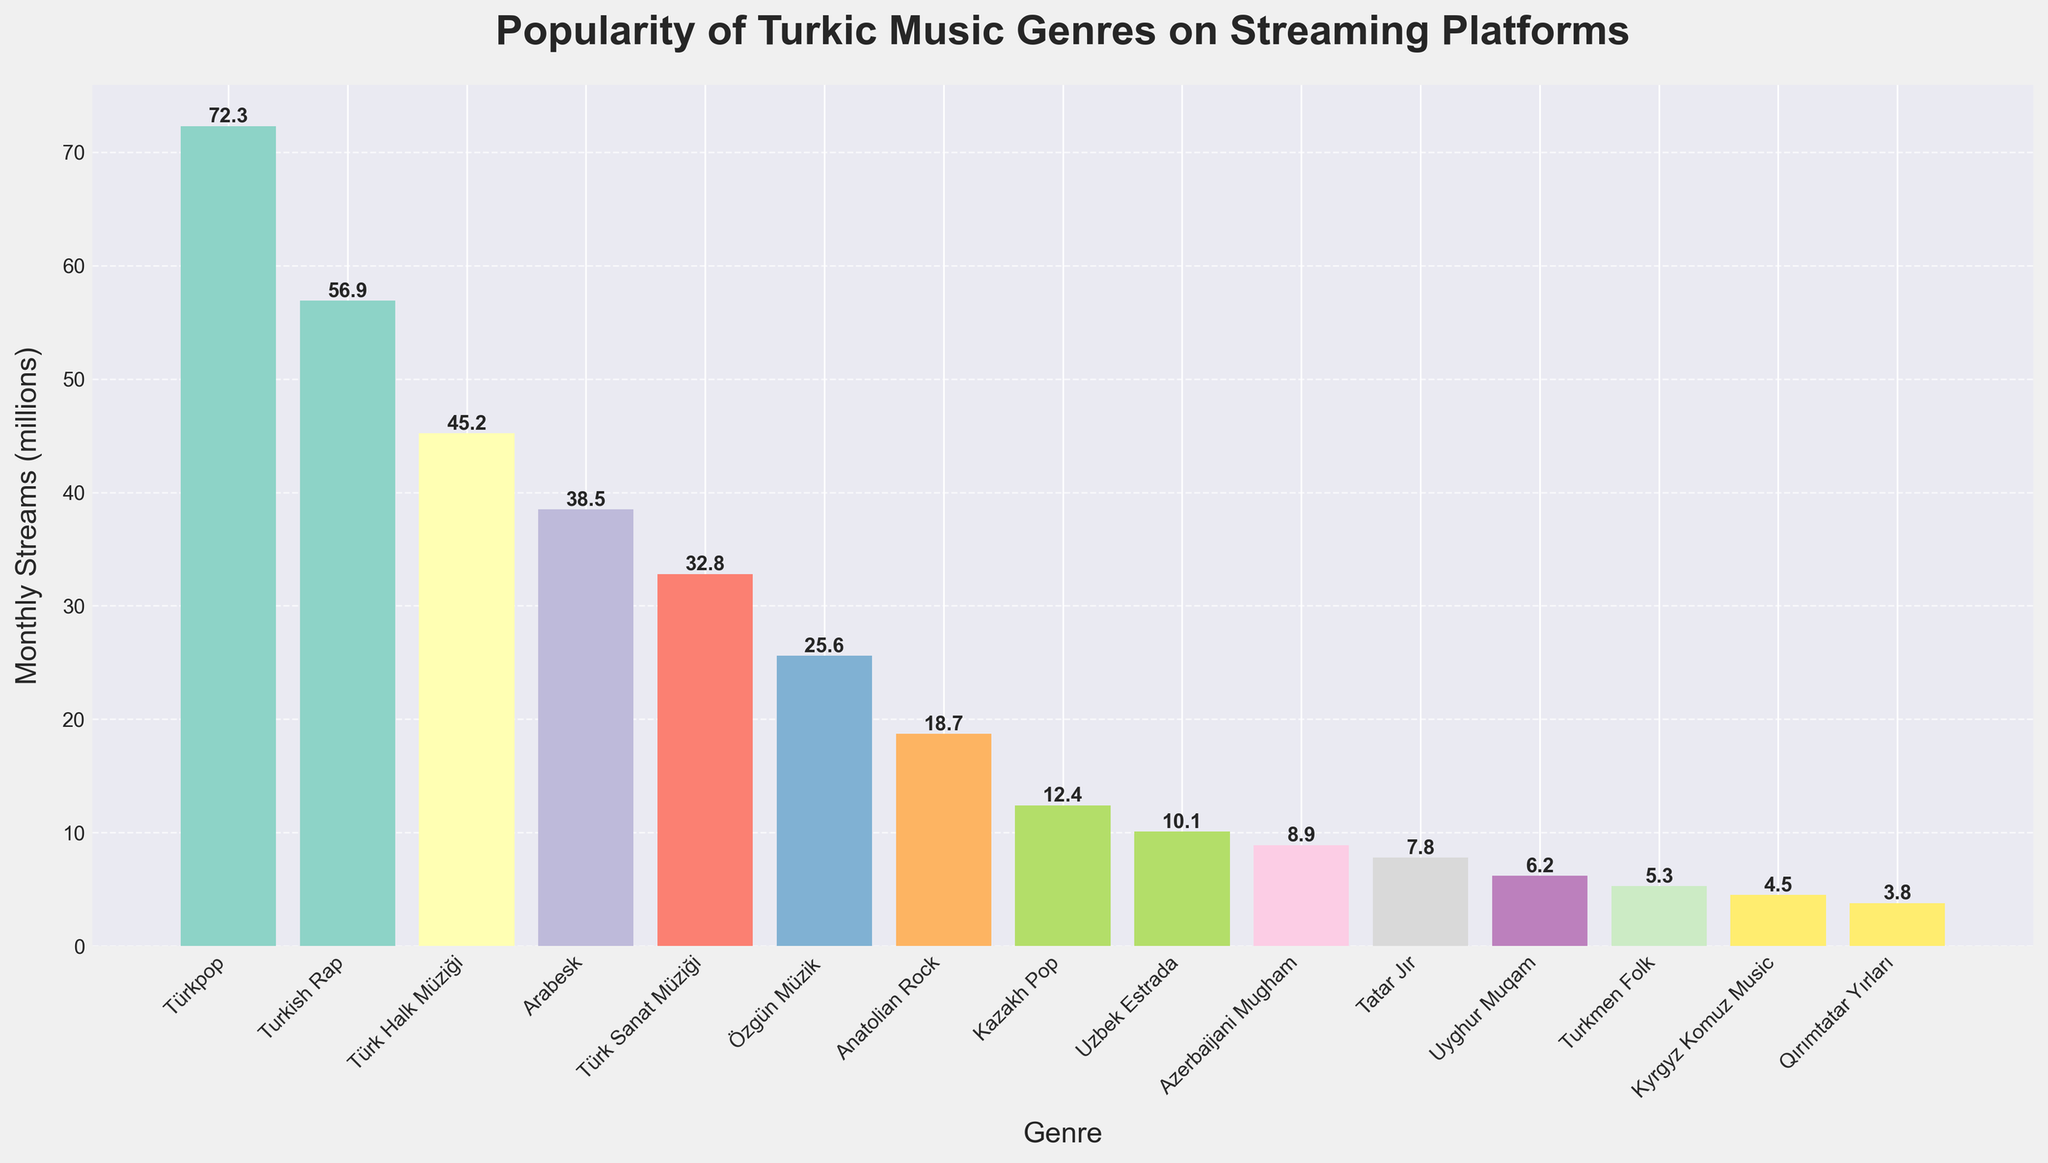Which Turkic music genre is the most popular on streaming platforms? Observing the bar chart, the highest bar represents Türkpop with the most monthly streams.
Answer: Türkpop How many genres have more than 30 million monthly streams? By examining the bars, four genres have monthly streams exceeding 30 million: Türkpop, Turkish Rap, Türk Halk Müziği, and Arabesk.
Answer: 4 What is the difference in popularity between Turkish Rap and Kazakh Pop? Turkish Rap has 56.9 million streams and Kazakh Pop has 12.4 million. Subtracting 12.4 from 56.9 gives the difference.
Answer: 44.5 million Which genre has the lowest monthly streams? The bar with the smallest height is for Qırımtatar Yırları, indicating the lowest monthly streams at 3.8 million.
Answer: Qırımtatar Yırları Which genre is more popular, Özgün Müzik or Uzbek Estrada? By comparing the heights of their respective bars, Özgün Müzik (25.6 million) has more streams than Uzbek Estrada (10.1 million).
Answer: Özgün Müzik What is the total number of monthly streams for all Turkic music genres? Summing the monthly streams for all listed genres: 45.2 + 32.8 + 38.5 + 72.3 + 18.7 + 25.6 + 8.9 + 12.4 + 10.1 + 5.3 + 3.8 + 6.2 + 4.5 + 7.8 + 56.9 = 349.2 million.
Answer: 349.2 million What is the average number of monthly streams for the genres listed? The total sum is 349.2 million, and there are 15 genres. Dividing 349.2 by 15 gives the average.
Answer: 23.28 million Which genre has nearly twice the monthly streams of Uyghur Muqam? Uyghur Muqam has 6.2 million monthly streams. Nearing this figure, Türk Halk Müziği has 45.2 million streams, which is almost twice as much.
Answer: Türk Halk Müziği How much more popular is Türk Halk Müziği compared to Anatolian Rock? Türk Halk Müziği has 45.2 million streams and Anatolian Rock has 18.7 million streams. Subtracting 18.7 from 45.2 gives the difference.
Answer: 26.5 million What is the combined popularity of Türk Halk Müziği and Turkish Rap? Adding the streams of Türk Halk Müziği and Turkish Rap: 45.2 + 56.9 = 102.1 million.
Answer: 102.1 million 